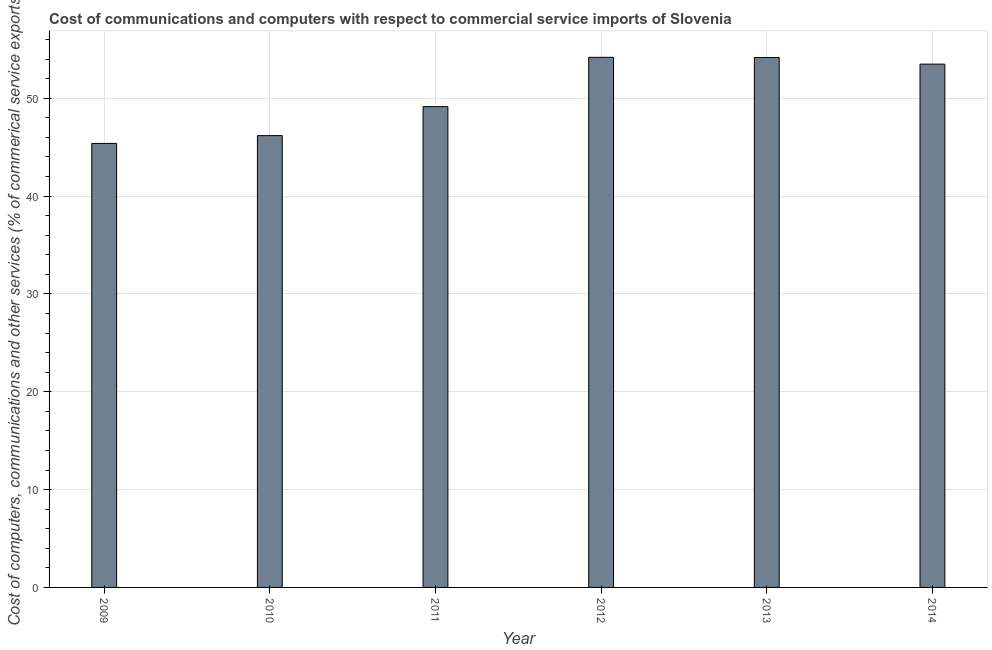Does the graph contain any zero values?
Offer a terse response. No. What is the title of the graph?
Your response must be concise. Cost of communications and computers with respect to commercial service imports of Slovenia. What is the label or title of the X-axis?
Make the answer very short. Year. What is the label or title of the Y-axis?
Keep it short and to the point. Cost of computers, communications and other services (% of commerical service exports). What is the cost of communications in 2011?
Make the answer very short. 49.15. Across all years, what is the maximum  computer and other services?
Keep it short and to the point. 54.19. Across all years, what is the minimum cost of communications?
Ensure brevity in your answer.  45.39. In which year was the  computer and other services maximum?
Ensure brevity in your answer.  2012. What is the sum of the cost of communications?
Make the answer very short. 302.58. What is the difference between the  computer and other services in 2010 and 2012?
Keep it short and to the point. -8. What is the average  computer and other services per year?
Your response must be concise. 50.43. What is the median cost of communications?
Give a very brief answer. 51.32. In how many years, is the  computer and other services greater than 38 %?
Your answer should be very brief. 6. Do a majority of the years between 2009 and 2011 (inclusive) have  computer and other services greater than 50 %?
Your answer should be very brief. No. What is the ratio of the cost of communications in 2011 to that in 2012?
Provide a succinct answer. 0.91. Is the  computer and other services in 2013 less than that in 2014?
Keep it short and to the point. No. What is the difference between the highest and the second highest  computer and other services?
Your answer should be compact. 0.02. Is the sum of the  computer and other services in 2009 and 2010 greater than the maximum  computer and other services across all years?
Provide a succinct answer. Yes. What is the difference between the highest and the lowest  computer and other services?
Keep it short and to the point. 8.8. In how many years, is the cost of communications greater than the average cost of communications taken over all years?
Offer a terse response. 3. How many bars are there?
Offer a very short reply. 6. How many years are there in the graph?
Provide a succinct answer. 6. What is the difference between two consecutive major ticks on the Y-axis?
Provide a short and direct response. 10. What is the Cost of computers, communications and other services (% of commerical service exports) in 2009?
Offer a very short reply. 45.39. What is the Cost of computers, communications and other services (% of commerical service exports) in 2010?
Provide a short and direct response. 46.19. What is the Cost of computers, communications and other services (% of commerical service exports) in 2011?
Make the answer very short. 49.15. What is the Cost of computers, communications and other services (% of commerical service exports) of 2012?
Your response must be concise. 54.19. What is the Cost of computers, communications and other services (% of commerical service exports) in 2013?
Ensure brevity in your answer.  54.17. What is the Cost of computers, communications and other services (% of commerical service exports) of 2014?
Make the answer very short. 53.5. What is the difference between the Cost of computers, communications and other services (% of commerical service exports) in 2009 and 2010?
Offer a very short reply. -0.8. What is the difference between the Cost of computers, communications and other services (% of commerical service exports) in 2009 and 2011?
Your answer should be very brief. -3.76. What is the difference between the Cost of computers, communications and other services (% of commerical service exports) in 2009 and 2012?
Give a very brief answer. -8.8. What is the difference between the Cost of computers, communications and other services (% of commerical service exports) in 2009 and 2013?
Provide a succinct answer. -8.79. What is the difference between the Cost of computers, communications and other services (% of commerical service exports) in 2009 and 2014?
Make the answer very short. -8.11. What is the difference between the Cost of computers, communications and other services (% of commerical service exports) in 2010 and 2011?
Provide a short and direct response. -2.96. What is the difference between the Cost of computers, communications and other services (% of commerical service exports) in 2010 and 2012?
Your response must be concise. -8. What is the difference between the Cost of computers, communications and other services (% of commerical service exports) in 2010 and 2013?
Offer a terse response. -7.99. What is the difference between the Cost of computers, communications and other services (% of commerical service exports) in 2010 and 2014?
Your response must be concise. -7.31. What is the difference between the Cost of computers, communications and other services (% of commerical service exports) in 2011 and 2012?
Provide a short and direct response. -5.04. What is the difference between the Cost of computers, communications and other services (% of commerical service exports) in 2011 and 2013?
Provide a succinct answer. -5.02. What is the difference between the Cost of computers, communications and other services (% of commerical service exports) in 2011 and 2014?
Your response must be concise. -4.35. What is the difference between the Cost of computers, communications and other services (% of commerical service exports) in 2012 and 2013?
Ensure brevity in your answer.  0.02. What is the difference between the Cost of computers, communications and other services (% of commerical service exports) in 2012 and 2014?
Your answer should be compact. 0.69. What is the difference between the Cost of computers, communications and other services (% of commerical service exports) in 2013 and 2014?
Offer a very short reply. 0.68. What is the ratio of the Cost of computers, communications and other services (% of commerical service exports) in 2009 to that in 2011?
Your answer should be very brief. 0.92. What is the ratio of the Cost of computers, communications and other services (% of commerical service exports) in 2009 to that in 2012?
Give a very brief answer. 0.84. What is the ratio of the Cost of computers, communications and other services (% of commerical service exports) in 2009 to that in 2013?
Offer a very short reply. 0.84. What is the ratio of the Cost of computers, communications and other services (% of commerical service exports) in 2009 to that in 2014?
Make the answer very short. 0.85. What is the ratio of the Cost of computers, communications and other services (% of commerical service exports) in 2010 to that in 2011?
Ensure brevity in your answer.  0.94. What is the ratio of the Cost of computers, communications and other services (% of commerical service exports) in 2010 to that in 2012?
Offer a very short reply. 0.85. What is the ratio of the Cost of computers, communications and other services (% of commerical service exports) in 2010 to that in 2013?
Provide a succinct answer. 0.85. What is the ratio of the Cost of computers, communications and other services (% of commerical service exports) in 2010 to that in 2014?
Make the answer very short. 0.86. What is the ratio of the Cost of computers, communications and other services (% of commerical service exports) in 2011 to that in 2012?
Offer a terse response. 0.91. What is the ratio of the Cost of computers, communications and other services (% of commerical service exports) in 2011 to that in 2013?
Keep it short and to the point. 0.91. What is the ratio of the Cost of computers, communications and other services (% of commerical service exports) in 2011 to that in 2014?
Your answer should be compact. 0.92. What is the ratio of the Cost of computers, communications and other services (% of commerical service exports) in 2012 to that in 2014?
Offer a terse response. 1.01. What is the ratio of the Cost of computers, communications and other services (% of commerical service exports) in 2013 to that in 2014?
Give a very brief answer. 1.01. 